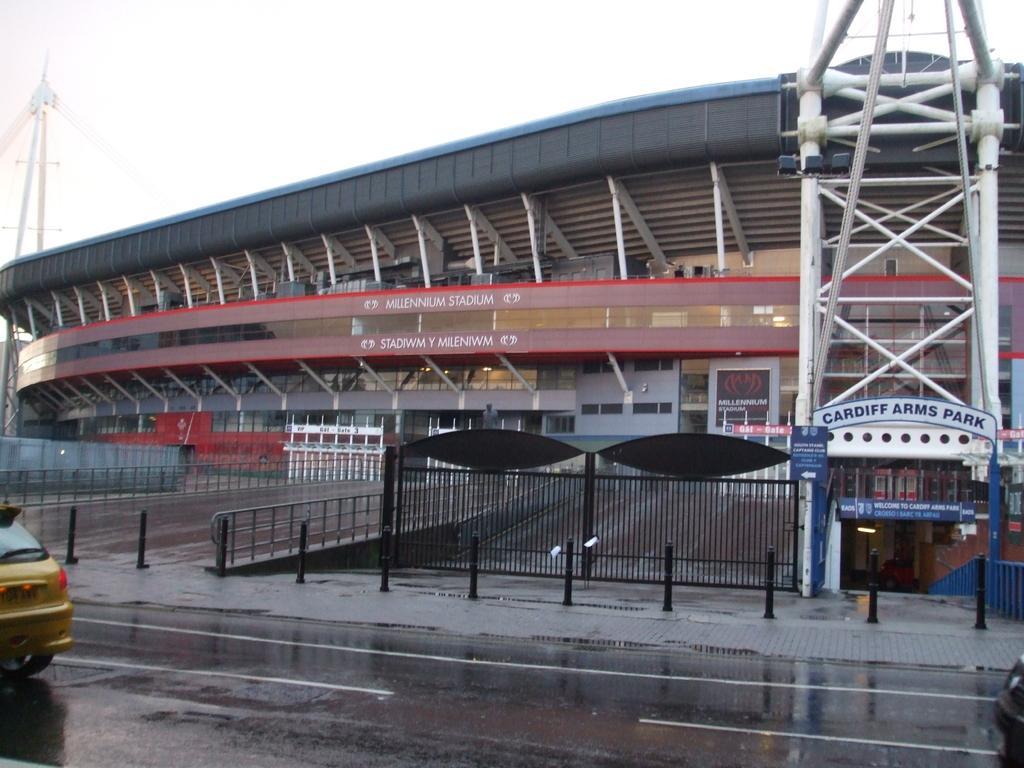How would you summarize this image in a sentence or two? In this image we can see a building with a sign board, lights, poles and some windows. We can also see a pathway with a fence and some divider poles. On the bottom of the image we can see some vehicles on the road, a footpath and a fence. On the backside we can see a tower and the sky which looks cloudy. 